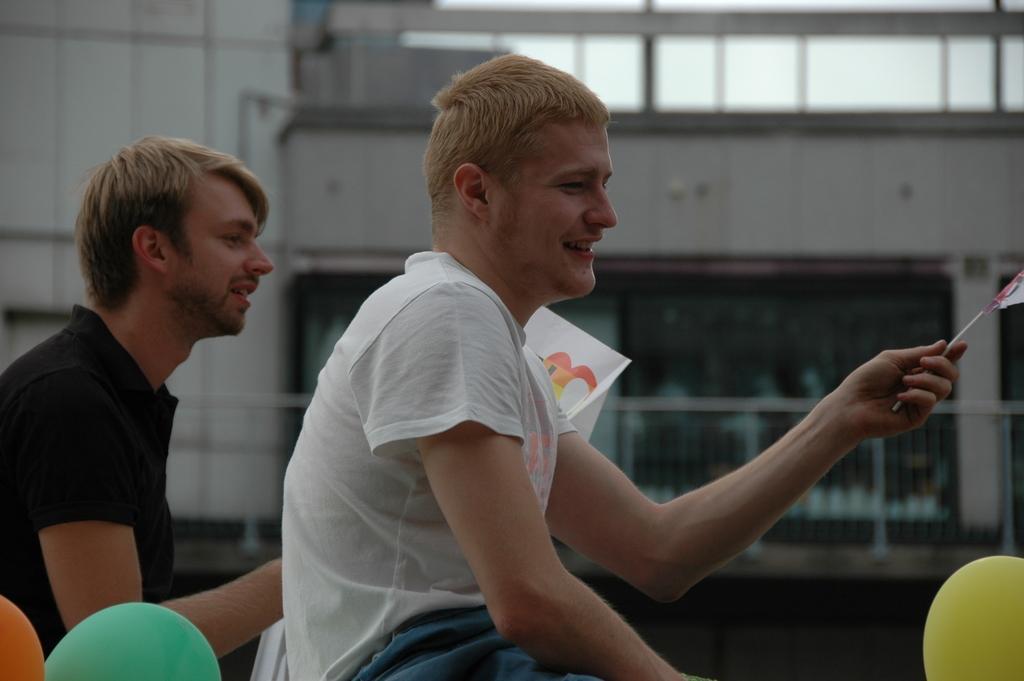Could you give a brief overview of what you see in this image? In this image we can see two persons. One person wearing a white t shirt is holding a flag in his hand. In the background, we can see a group of balloons, metal barricade and a building. 